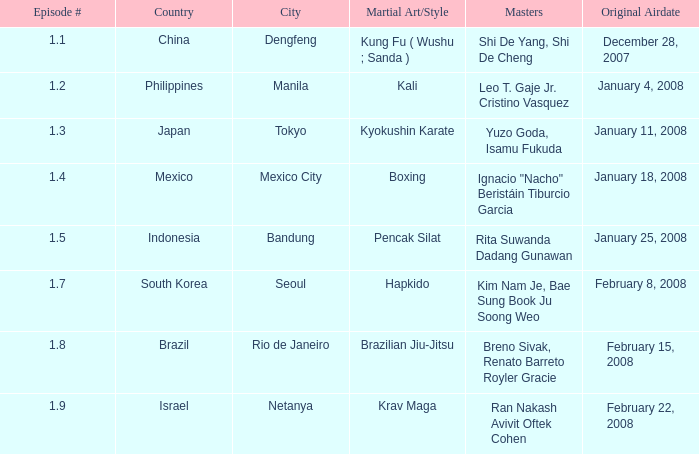When did the episode featuring a master using Brazilian jiu-jitsu air? February 15, 2008. 